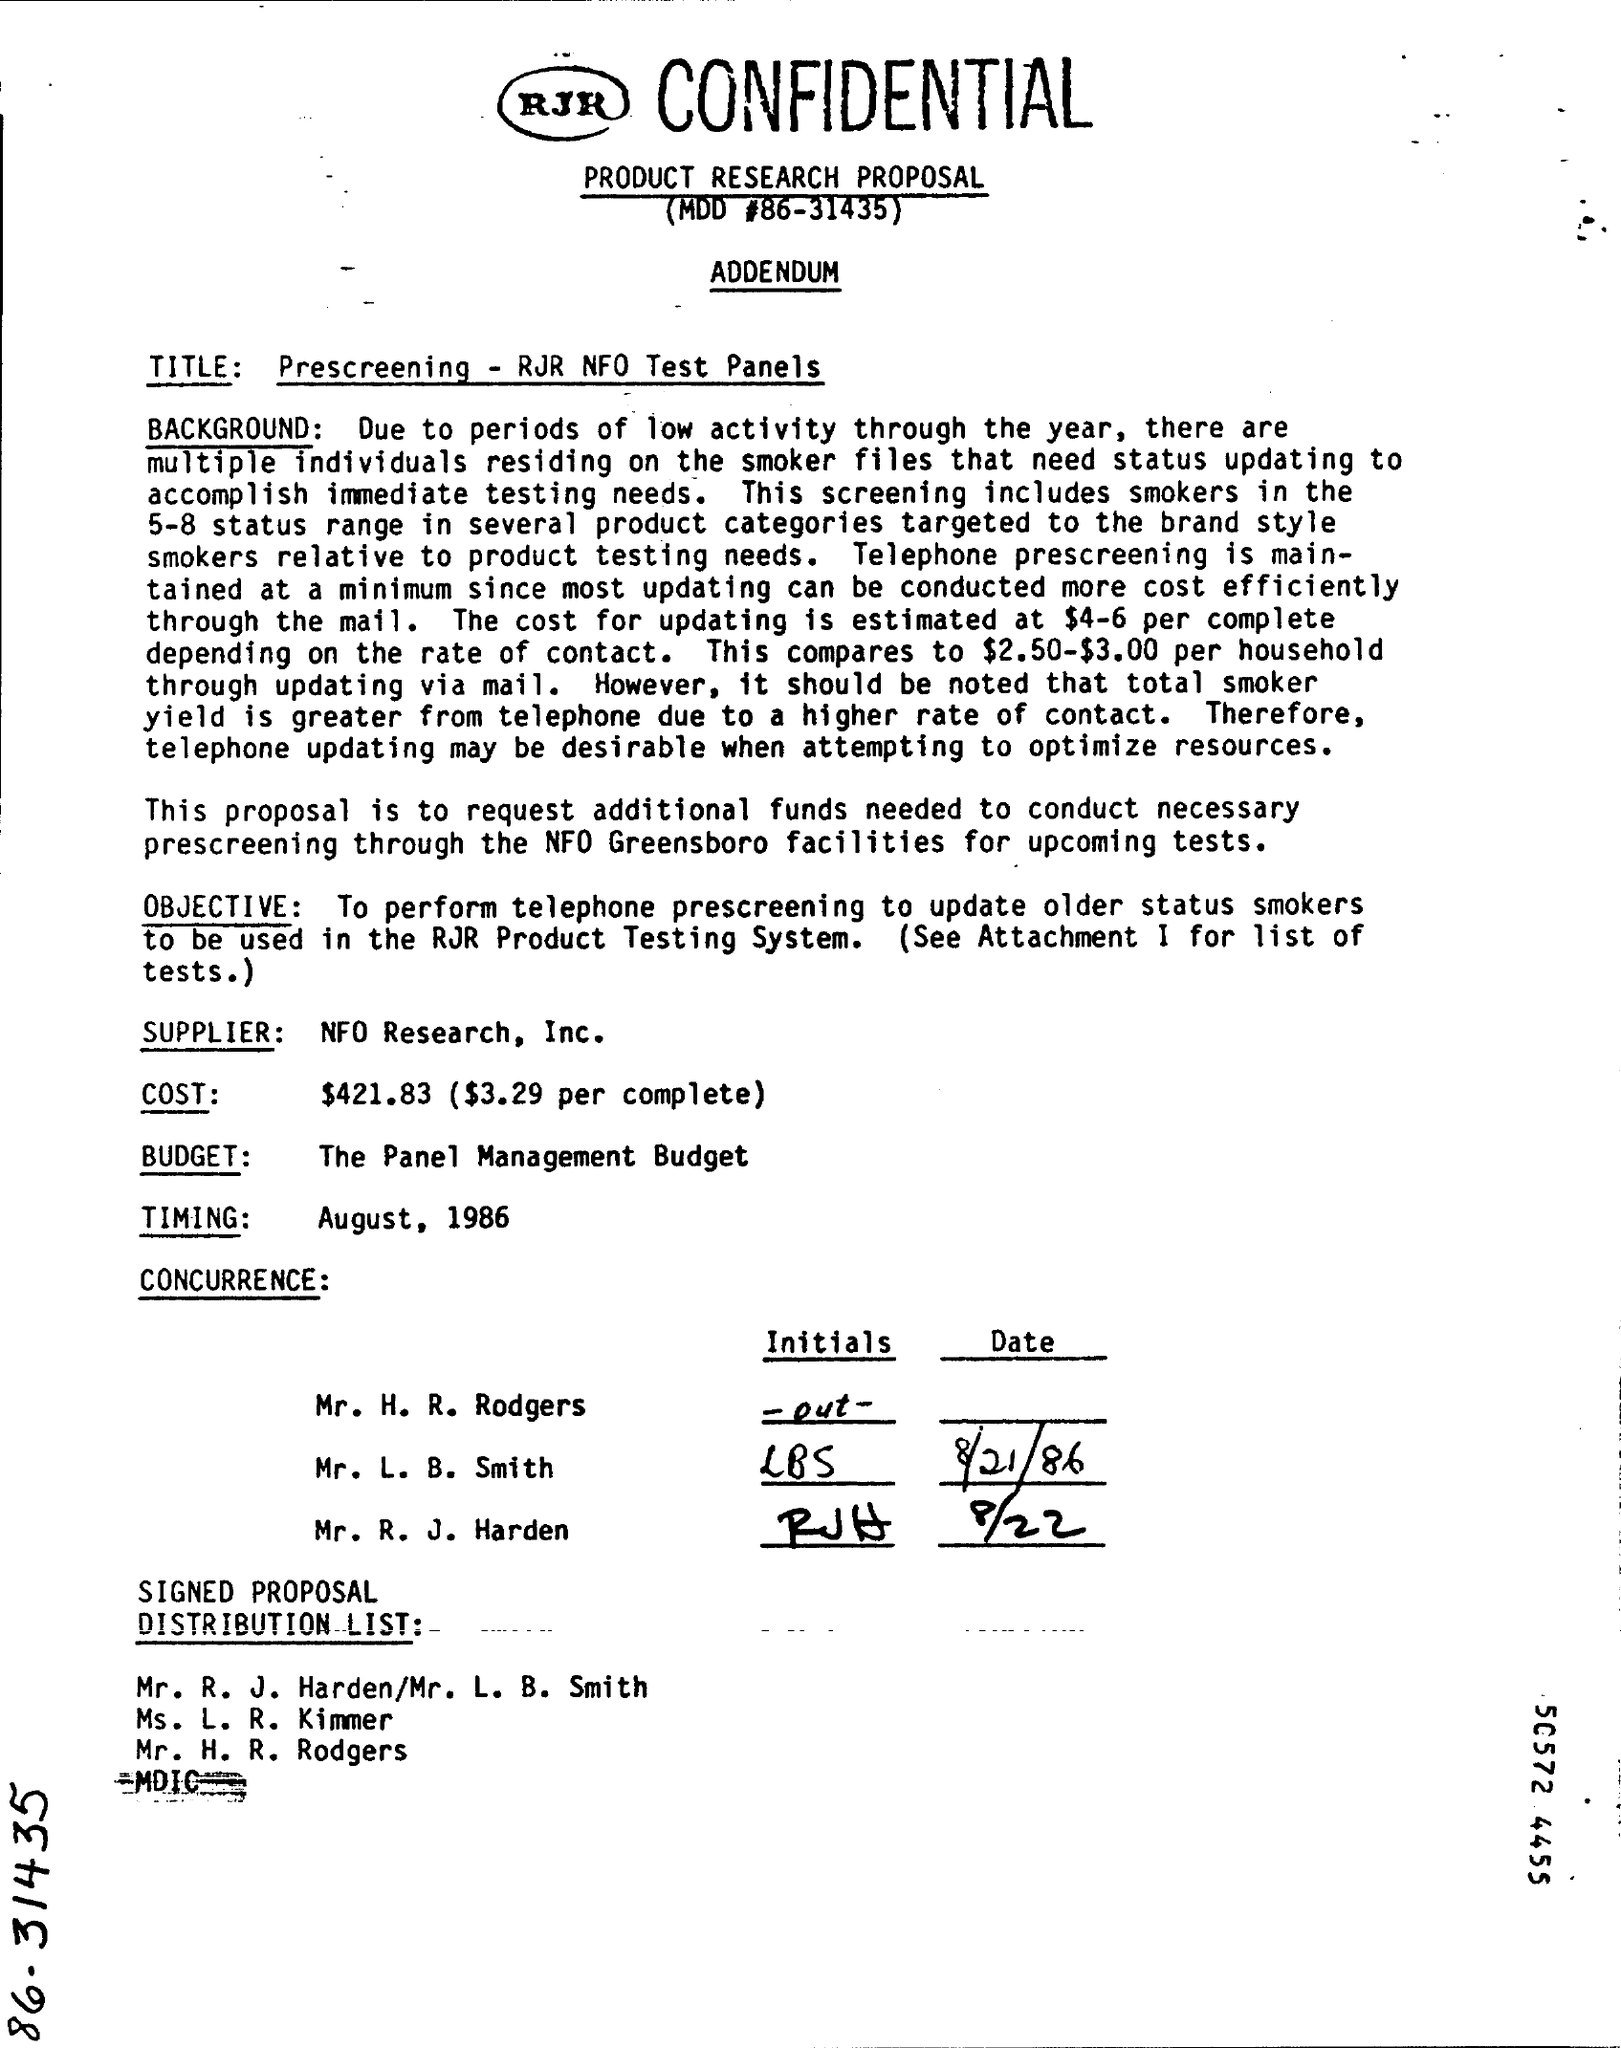Point out several critical features in this image. The cost of updating through emails is estimated to be between $2.50 and $3.00 per household. The estimated cost of contact rate varies between $4 and $6. 